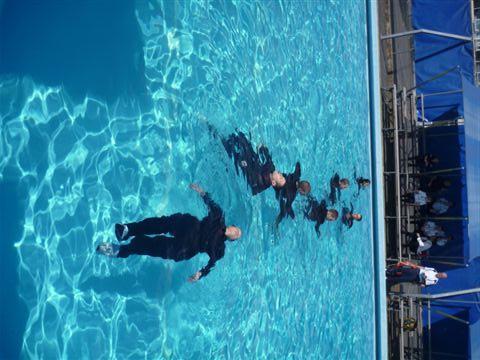How many people are there?
Give a very brief answer. 2. 